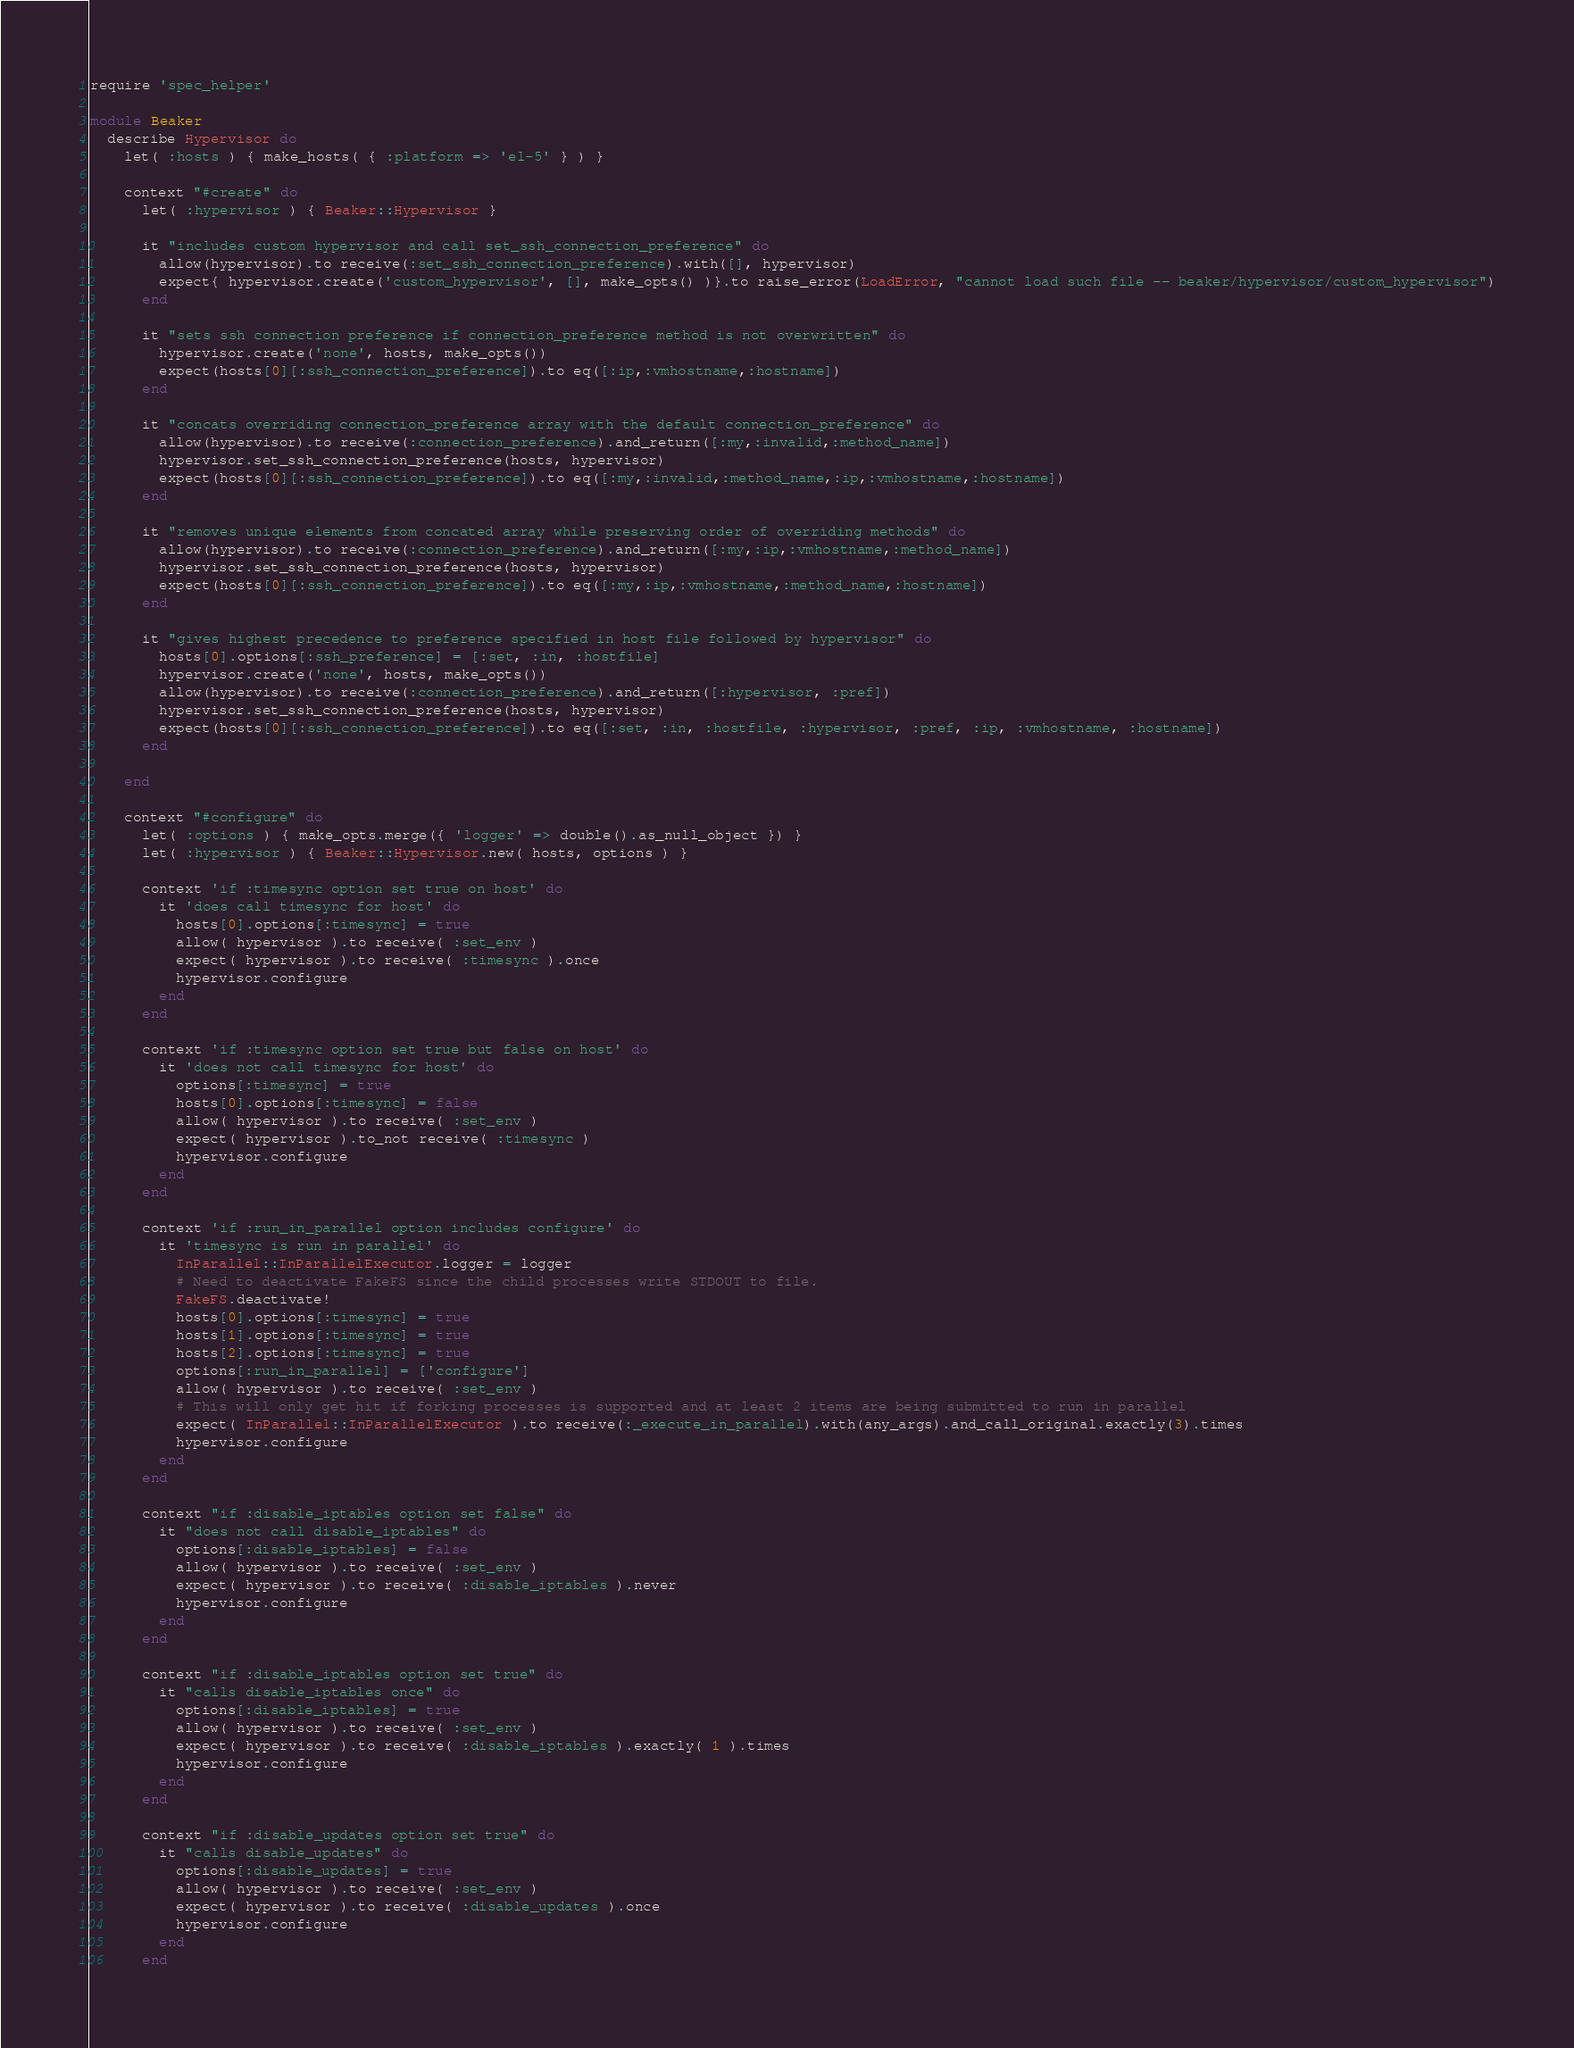<code> <loc_0><loc_0><loc_500><loc_500><_Ruby_>require 'spec_helper'

module Beaker
  describe Hypervisor do
    let( :hosts ) { make_hosts( { :platform => 'el-5' } ) }

    context "#create" do
      let( :hypervisor ) { Beaker::Hypervisor }

      it "includes custom hypervisor and call set_ssh_connection_preference" do
        allow(hypervisor).to receive(:set_ssh_connection_preference).with([], hypervisor)
        expect{ hypervisor.create('custom_hypervisor', [], make_opts() )}.to raise_error(LoadError, "cannot load such file -- beaker/hypervisor/custom_hypervisor")
      end

      it "sets ssh connection preference if connection_preference method is not overwritten" do
        hypervisor.create('none', hosts, make_opts())
        expect(hosts[0][:ssh_connection_preference]).to eq([:ip,:vmhostname,:hostname])
      end

      it "concats overriding connection_preference array with the default connection_preference" do
        allow(hypervisor).to receive(:connection_preference).and_return([:my,:invalid,:method_name])
        hypervisor.set_ssh_connection_preference(hosts, hypervisor)
        expect(hosts[0][:ssh_connection_preference]).to eq([:my,:invalid,:method_name,:ip,:vmhostname,:hostname])
      end

      it "removes unique elements from concated array while preserving order of overriding methods" do
        allow(hypervisor).to receive(:connection_preference).and_return([:my,:ip,:vmhostname,:method_name])
        hypervisor.set_ssh_connection_preference(hosts, hypervisor)
        expect(hosts[0][:ssh_connection_preference]).to eq([:my,:ip,:vmhostname,:method_name,:hostname])
      end

      it "gives highest precedence to preference specified in host file followed by hypervisor" do
        hosts[0].options[:ssh_preference] = [:set, :in, :hostfile]
        hypervisor.create('none', hosts, make_opts())
        allow(hypervisor).to receive(:connection_preference).and_return([:hypervisor, :pref])
        hypervisor.set_ssh_connection_preference(hosts, hypervisor)
        expect(hosts[0][:ssh_connection_preference]).to eq([:set, :in, :hostfile, :hypervisor, :pref, :ip, :vmhostname, :hostname])
      end

    end

    context "#configure" do
      let( :options ) { make_opts.merge({ 'logger' => double().as_null_object }) }
      let( :hypervisor ) { Beaker::Hypervisor.new( hosts, options ) }

      context 'if :timesync option set true on host' do
        it 'does call timesync for host' do
          hosts[0].options[:timesync] = true
          allow( hypervisor ).to receive( :set_env )
          expect( hypervisor ).to receive( :timesync ).once
          hypervisor.configure
        end
      end

      context 'if :timesync option set true but false on host' do
        it 'does not call timesync for host' do
          options[:timesync] = true
          hosts[0].options[:timesync] = false
          allow( hypervisor ).to receive( :set_env )
          expect( hypervisor ).to_not receive( :timesync )
          hypervisor.configure
        end
      end

      context 'if :run_in_parallel option includes configure' do
        it 'timesync is run in parallel' do
          InParallel::InParallelExecutor.logger = logger
          # Need to deactivate FakeFS since the child processes write STDOUT to file.
          FakeFS.deactivate!
          hosts[0].options[:timesync] = true
          hosts[1].options[:timesync] = true
          hosts[2].options[:timesync] = true
          options[:run_in_parallel] = ['configure']
          allow( hypervisor ).to receive( :set_env )
          # This will only get hit if forking processes is supported and at least 2 items are being submitted to run in parallel
          expect( InParallel::InParallelExecutor ).to receive(:_execute_in_parallel).with(any_args).and_call_original.exactly(3).times
          hypervisor.configure
        end
      end

      context "if :disable_iptables option set false" do
        it "does not call disable_iptables" do
          options[:disable_iptables] = false
          allow( hypervisor ).to receive( :set_env )
          expect( hypervisor ).to receive( :disable_iptables ).never
          hypervisor.configure
        end
      end

      context "if :disable_iptables option set true" do
        it "calls disable_iptables once" do
          options[:disable_iptables] = true
          allow( hypervisor ).to receive( :set_env )
          expect( hypervisor ).to receive( :disable_iptables ).exactly( 1 ).times
          hypervisor.configure
        end
      end

      context "if :disable_updates option set true" do
        it "calls disable_updates" do
          options[:disable_updates] = true
          allow( hypervisor ).to receive( :set_env )
          expect( hypervisor ).to receive( :disable_updates ).once
          hypervisor.configure
        end
      end
</code> 